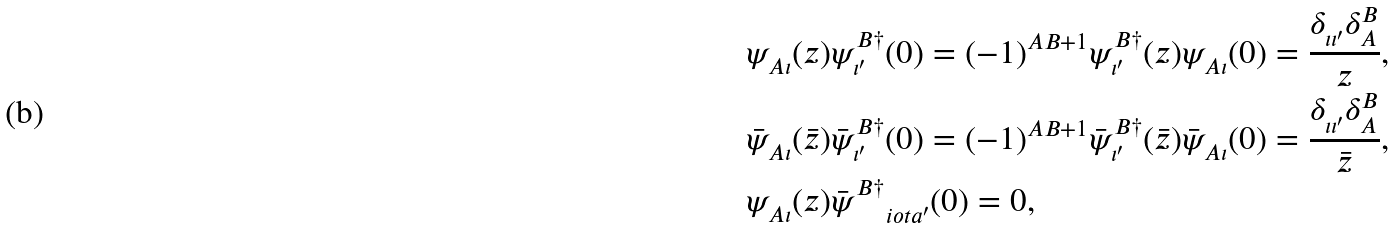Convert formula to latex. <formula><loc_0><loc_0><loc_500><loc_500>& \psi ^ { \ } _ { A \iota } ( z ) \psi ^ { B \dag } _ { \iota ^ { \prime } } ( 0 ) = ( - 1 ) ^ { A B + 1 } \psi ^ { B \dag } _ { \iota ^ { \prime } } ( z ) \psi ^ { \ } _ { A \iota } ( 0 ) = \frac { \delta ^ { \ } _ { \iota \iota ^ { \prime } } \delta ^ { B } _ { A } } { z } , \\ & \bar { \psi } ^ { \ } _ { A \iota } ( \bar { z } ) \bar { \psi } ^ { B \dag } _ { \iota ^ { \prime } } ( 0 ) = ( - 1 ) ^ { A B + 1 } \bar { \psi } ^ { B \dag } _ { \iota ^ { \prime } } ( \bar { z } ) \bar { \psi } ^ { \ } _ { A \iota } ( 0 ) = \frac { \delta ^ { \ } _ { \iota \iota ^ { \prime } } \delta ^ { B } _ { A } } { \bar { z } } , \\ & \psi ^ { \ } _ { A \iota } ( z ) \bar { \psi } ^ { B \dag } _ { \quad i o t a ^ { \prime } } ( 0 ) = 0 ,</formula> 